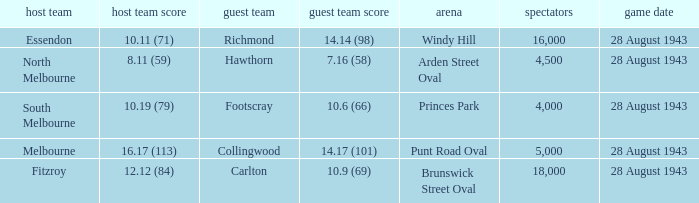What game showed a home team score of 8.11 (59)? 28 August 1943. 